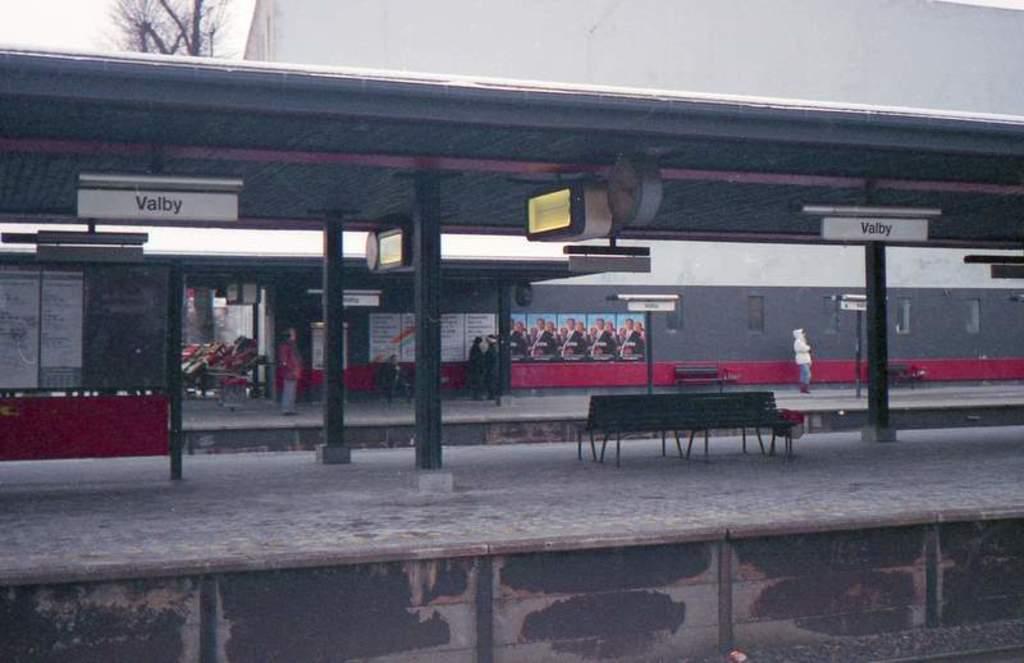In one or two sentences, can you explain what this image depicts? In this picture I can observe railway station. In the middle of the picture there are benches on the platform. In the background I can observe a building and tree. 